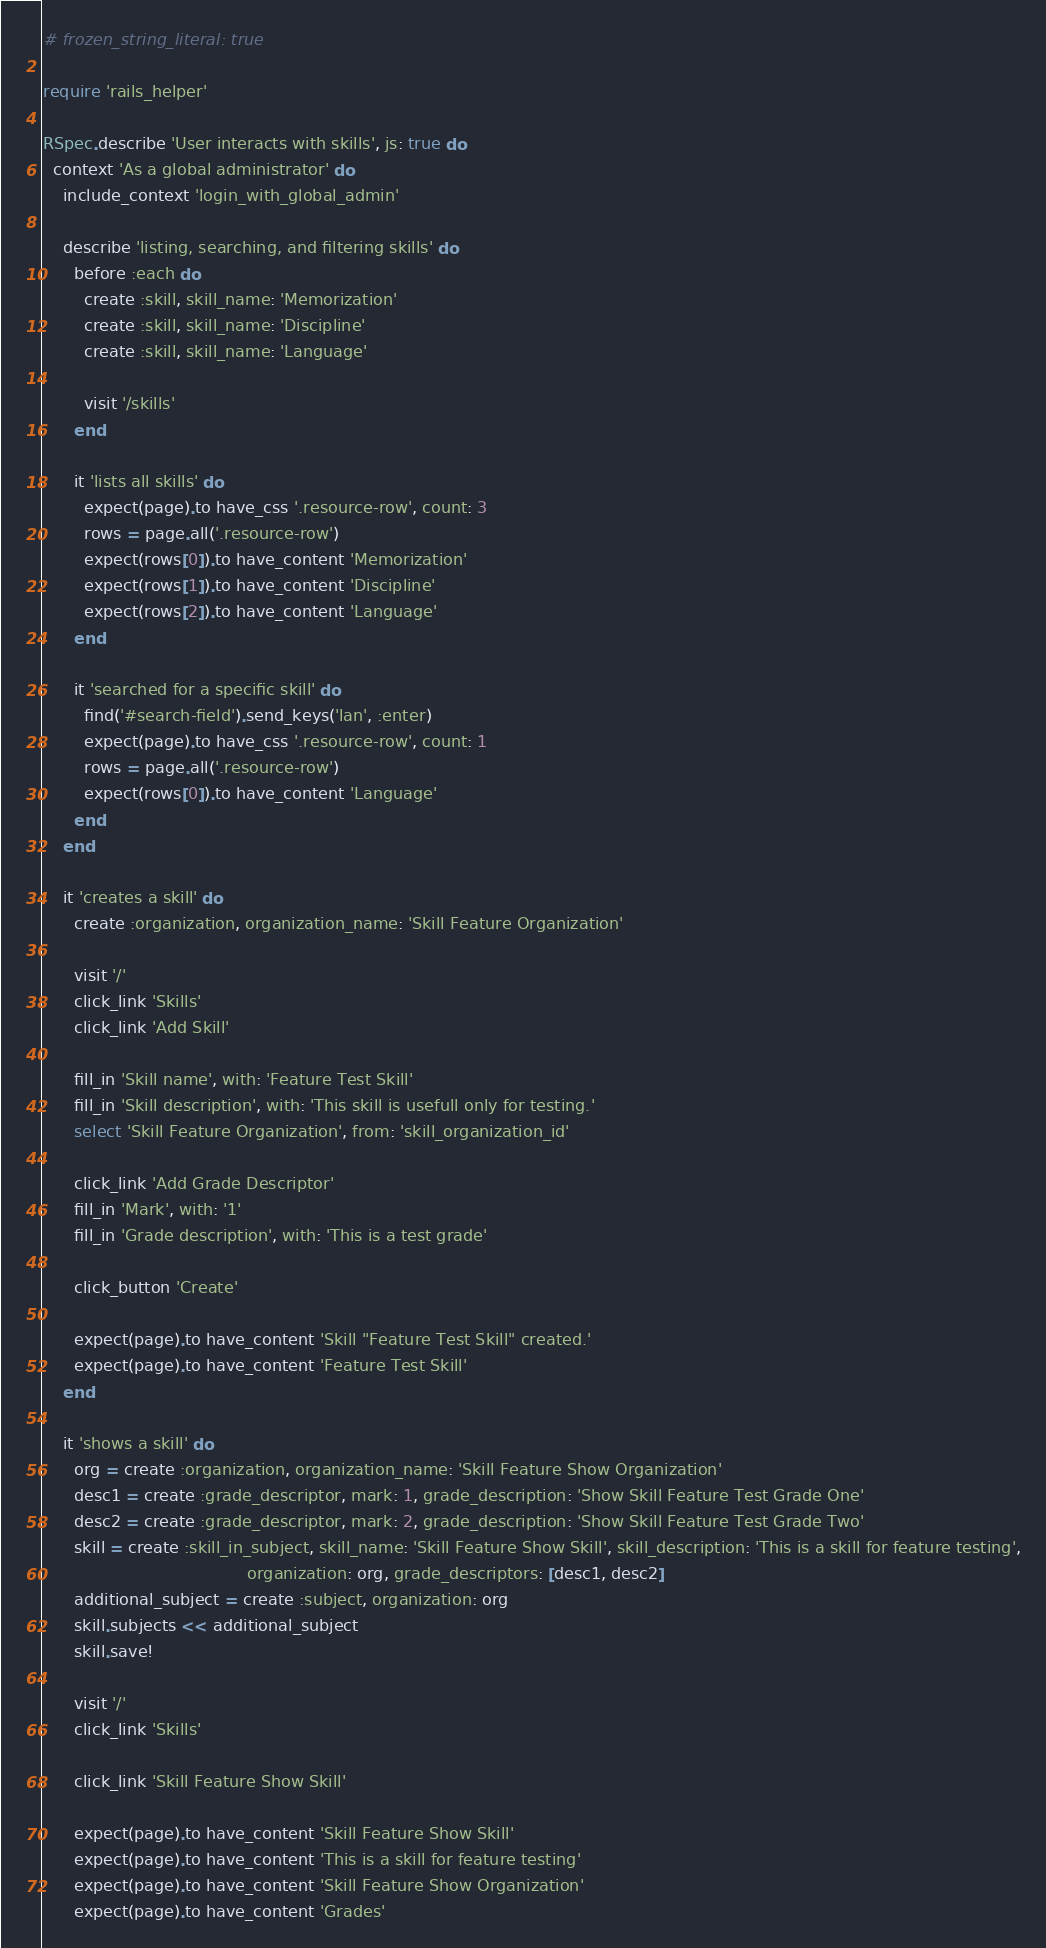<code> <loc_0><loc_0><loc_500><loc_500><_Ruby_># frozen_string_literal: true

require 'rails_helper'

RSpec.describe 'User interacts with skills', js: true do
  context 'As a global administrator' do
    include_context 'login_with_global_admin'

    describe 'listing, searching, and filtering skills' do
      before :each do
        create :skill, skill_name: 'Memorization'
        create :skill, skill_name: 'Discipline'
        create :skill, skill_name: 'Language'

        visit '/skills'
      end

      it 'lists all skills' do
        expect(page).to have_css '.resource-row', count: 3
        rows = page.all('.resource-row')
        expect(rows[0]).to have_content 'Memorization'
        expect(rows[1]).to have_content 'Discipline'
        expect(rows[2]).to have_content 'Language'
      end

      it 'searched for a specific skill' do
        find('#search-field').send_keys('lan', :enter)
        expect(page).to have_css '.resource-row', count: 1
        rows = page.all('.resource-row')
        expect(rows[0]).to have_content 'Language'
      end
    end

    it 'creates a skill' do
      create :organization, organization_name: 'Skill Feature Organization'

      visit '/'
      click_link 'Skills'
      click_link 'Add Skill'

      fill_in 'Skill name', with: 'Feature Test Skill'
      fill_in 'Skill description', with: 'This skill is usefull only for testing.'
      select 'Skill Feature Organization', from: 'skill_organization_id'

      click_link 'Add Grade Descriptor'
      fill_in 'Mark', with: '1'
      fill_in 'Grade description', with: 'This is a test grade'

      click_button 'Create'

      expect(page).to have_content 'Skill "Feature Test Skill" created.'
      expect(page).to have_content 'Feature Test Skill'
    end

    it 'shows a skill' do
      org = create :organization, organization_name: 'Skill Feature Show Organization'
      desc1 = create :grade_descriptor, mark: 1, grade_description: 'Show Skill Feature Test Grade One'
      desc2 = create :grade_descriptor, mark: 2, grade_description: 'Show Skill Feature Test Grade Two'
      skill = create :skill_in_subject, skill_name: 'Skill Feature Show Skill', skill_description: 'This is a skill for feature testing',
                                        organization: org, grade_descriptors: [desc1, desc2]
      additional_subject = create :subject, organization: org
      skill.subjects << additional_subject
      skill.save!

      visit '/'
      click_link 'Skills'

      click_link 'Skill Feature Show Skill'

      expect(page).to have_content 'Skill Feature Show Skill'
      expect(page).to have_content 'This is a skill for feature testing'
      expect(page).to have_content 'Skill Feature Show Organization'
      expect(page).to have_content 'Grades'</code> 